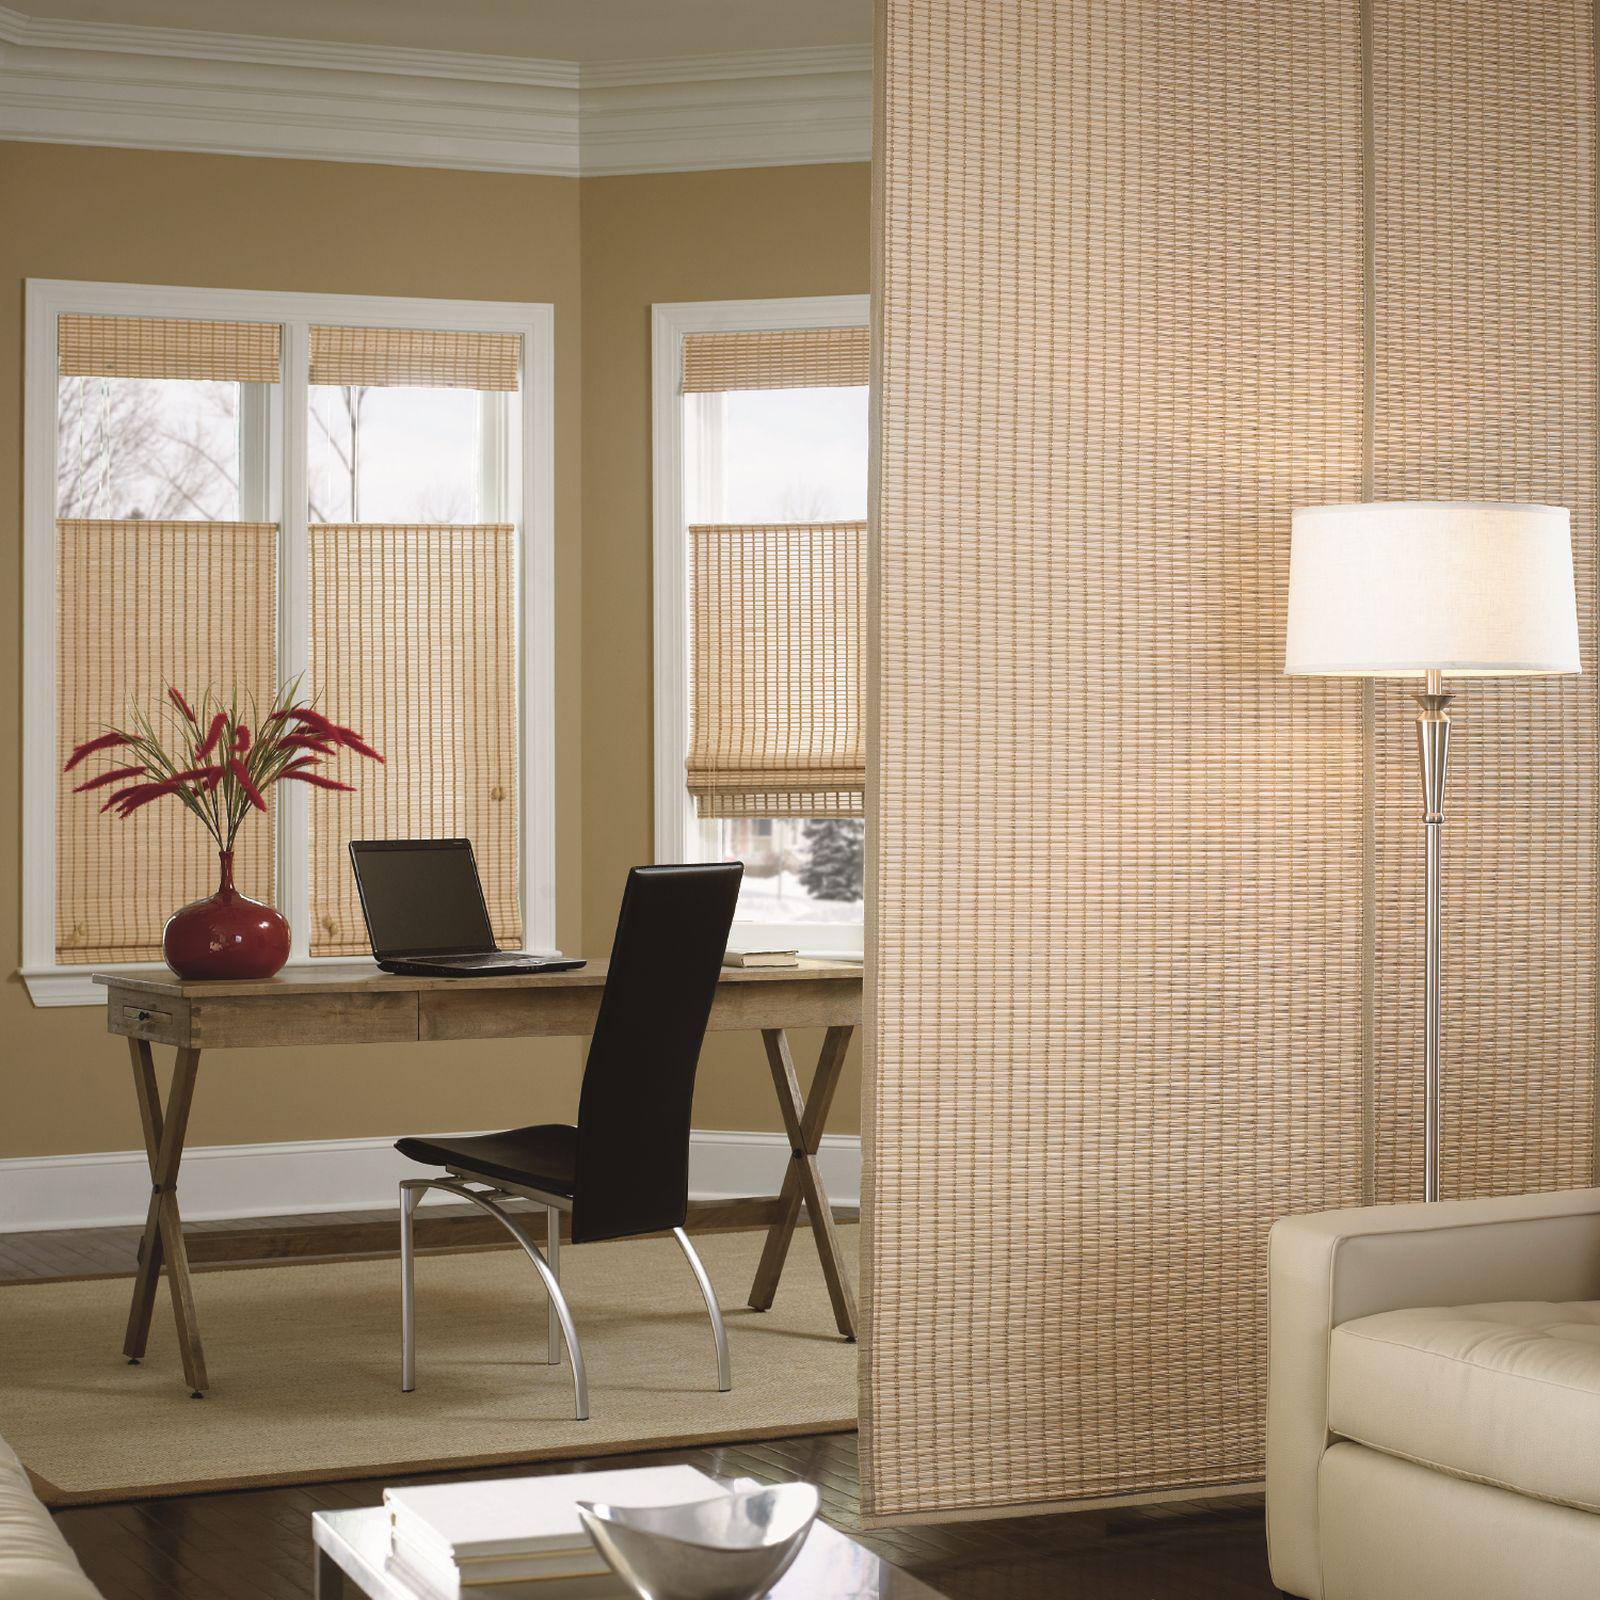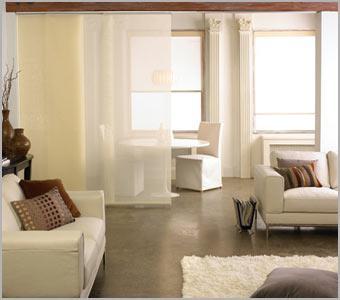The first image is the image on the left, the second image is the image on the right. Analyze the images presented: Is the assertion "An image with a tall lamp at the right includes at least three beige window shades with the upper part of the windows uncovered." valid? Answer yes or no. Yes. The first image is the image on the left, the second image is the image on the right. For the images shown, is this caption "The left and right image contains a total of five windows raised off the floor." true? Answer yes or no. Yes. 